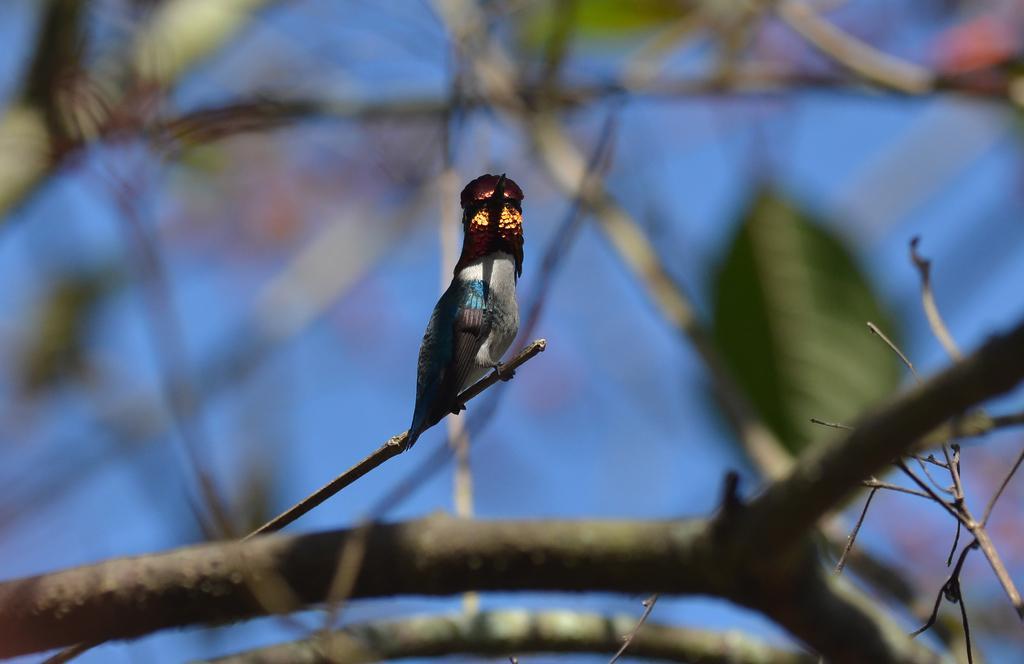In one or two sentences, can you explain what this image depicts? In this picture we can see a bird on a twig. Background portion of the picture is blur. 